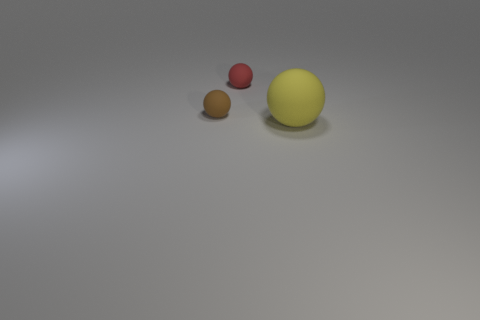What might be the context or setting of this image? The image appears to be a minimalistic and staged composition, possibly for a graphical representation or a study in color and form contrast. The smooth surface and uniform lighting suggest an artificial, controlled environment. 